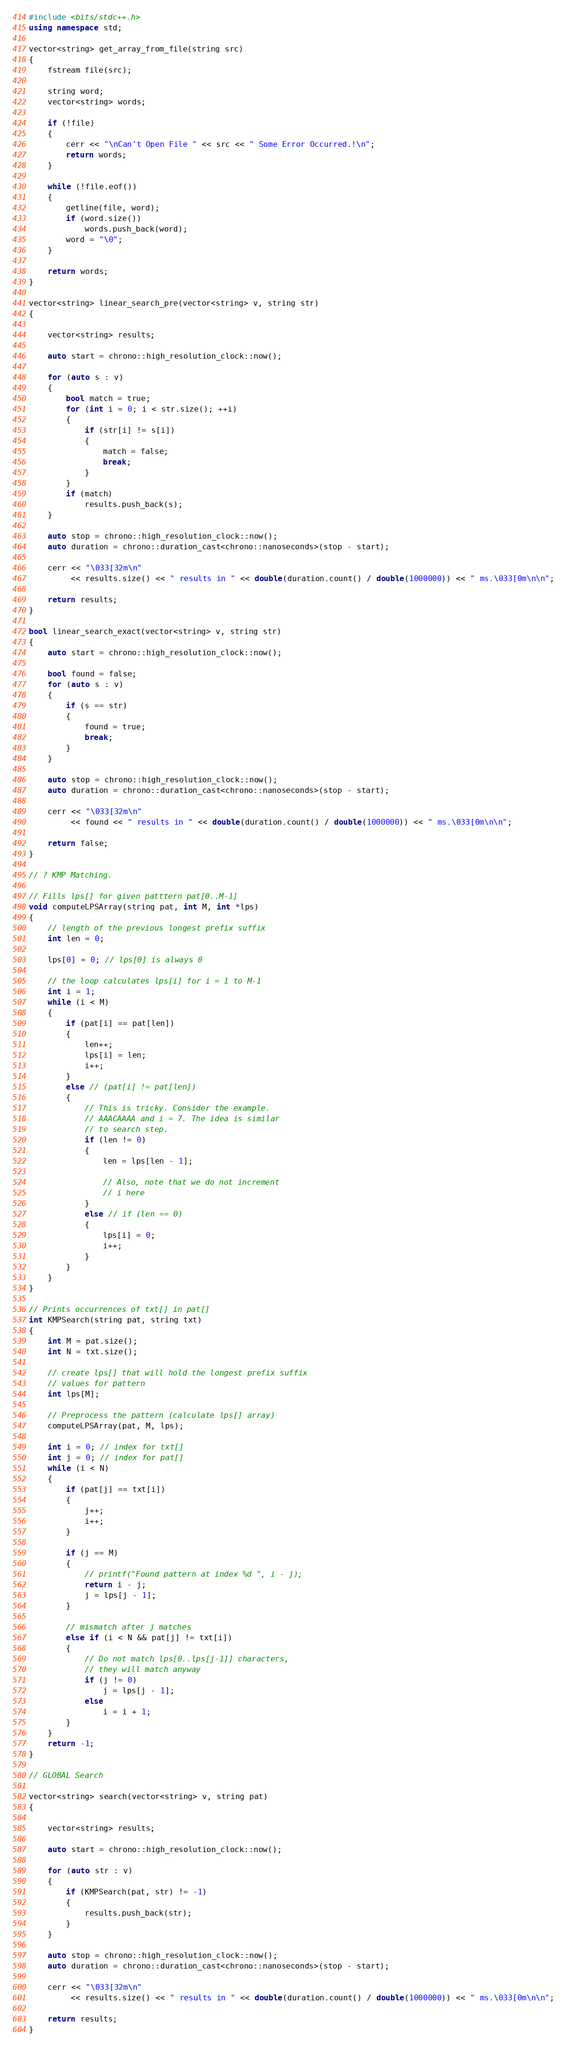Convert code to text. <code><loc_0><loc_0><loc_500><loc_500><_C++_>#include <bits/stdc++.h>
using namespace std;

vector<string> get_array_from_file(string src)
{
    fstream file(src);

    string word;
    vector<string> words;

    if (!file)
    {
        cerr << "\nCan't Open File " << src << " Some Error Occurred.!\n";
        return words;
    }

    while (!file.eof())
    {
        getline(file, word);
        if (word.size())
            words.push_back(word);
        word = "\0";
    }

    return words;
}

vector<string> linear_search_pre(vector<string> v, string str)
{

    vector<string> results;

    auto start = chrono::high_resolution_clock::now();

    for (auto s : v)
    {
        bool match = true;
        for (int i = 0; i < str.size(); ++i)
        {
            if (str[i] != s[i])
            {
                match = false;
                break;
            }
        }
        if (match)
            results.push_back(s);
    }

    auto stop = chrono::high_resolution_clock::now();
    auto duration = chrono::duration_cast<chrono::nanoseconds>(stop - start);

    cerr << "\033[32m\n"
         << results.size() << " results in " << double(duration.count() / double(1000000)) << " ms.\033[0m\n\n";

    return results;
}

bool linear_search_exact(vector<string> v, string str)
{
    auto start = chrono::high_resolution_clock::now();

    bool found = false;
    for (auto s : v)
    {
        if (s == str)
        {
            found = true;
            break;
        }
    }

    auto stop = chrono::high_resolution_clock::now();
    auto duration = chrono::duration_cast<chrono::nanoseconds>(stop - start);

    cerr << "\033[32m\n"
         << found << " results in " << double(duration.count() / double(1000000)) << " ms.\033[0m\n\n";

    return false;
}

// ? KMP Matching.

// Fills lps[] for given patttern pat[0..M-1]
void computeLPSArray(string pat, int M, int *lps)
{
    // length of the previous longest prefix suffix
    int len = 0;

    lps[0] = 0; // lps[0] is always 0

    // the loop calculates lps[i] for i = 1 to M-1
    int i = 1;
    while (i < M)
    {
        if (pat[i] == pat[len])
        {
            len++;
            lps[i] = len;
            i++;
        }
        else // (pat[i] != pat[len])
        {
            // This is tricky. Consider the example.
            // AAACAAAA and i = 7. The idea is similar
            // to search step.
            if (len != 0)
            {
                len = lps[len - 1];

                // Also, note that we do not increment
                // i here
            }
            else // if (len == 0)
            {
                lps[i] = 0;
                i++;
            }
        }
    }
}

// Prints occurrences of txt[] in pat[]
int KMPSearch(string pat, string txt)
{
    int M = pat.size();
    int N = txt.size();

    // create lps[] that will hold the longest prefix suffix
    // values for pattern
    int lps[M];

    // Preprocess the pattern (calculate lps[] array)
    computeLPSArray(pat, M, lps);

    int i = 0; // index for txt[]
    int j = 0; // index for pat[]
    while (i < N)
    {
        if (pat[j] == txt[i])
        {
            j++;
            i++;
        }

        if (j == M)
        {
            // printf("Found pattern at index %d ", i - j);
            return i - j;
            j = lps[j - 1];
        }

        // mismatch after j matches
        else if (i < N && pat[j] != txt[i])
        {
            // Do not match lps[0..lps[j-1]] characters,
            // they will match anyway
            if (j != 0)
                j = lps[j - 1];
            else
                i = i + 1;
        }
    }
    return -1;
}

// GLOBAL Search

vector<string> search(vector<string> v, string pat)
{

    vector<string> results;

    auto start = chrono::high_resolution_clock::now();

    for (auto str : v)
    {
        if (KMPSearch(pat, str) != -1)
        {
            results.push_back(str);
        }
    }

    auto stop = chrono::high_resolution_clock::now();
    auto duration = chrono::duration_cast<chrono::nanoseconds>(stop - start);

    cerr << "\033[32m\n"
         << results.size() << " results in " << double(duration.count() / double(1000000)) << " ms.\033[0m\n\n";

    return results;
}
</code> 